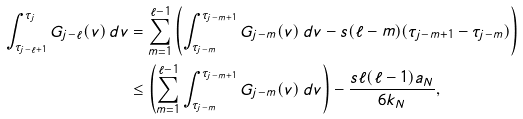Convert formula to latex. <formula><loc_0><loc_0><loc_500><loc_500>\int _ { \tau _ { j - \ell + 1 } } ^ { \tau _ { j } } G _ { j - \ell } ( v ) \, d v & = \sum _ { m = 1 } ^ { \ell - 1 } \left ( \int _ { \tau _ { j - m } } ^ { \tau _ { j - m + 1 } } G _ { j - m } ( v ) \, d v - s ( \ell - m ) ( \tau _ { j - m + 1 } - \tau _ { j - m } ) \right ) \\ & \leq \left ( \sum _ { m = 1 } ^ { \ell - 1 } \int _ { \tau _ { j - m } } ^ { \tau _ { j - m + 1 } } G _ { j - m } ( v ) \, d v \right ) - \frac { s \ell ( \ell - 1 ) a _ { N } } { 6 k _ { N } } ,</formula> 